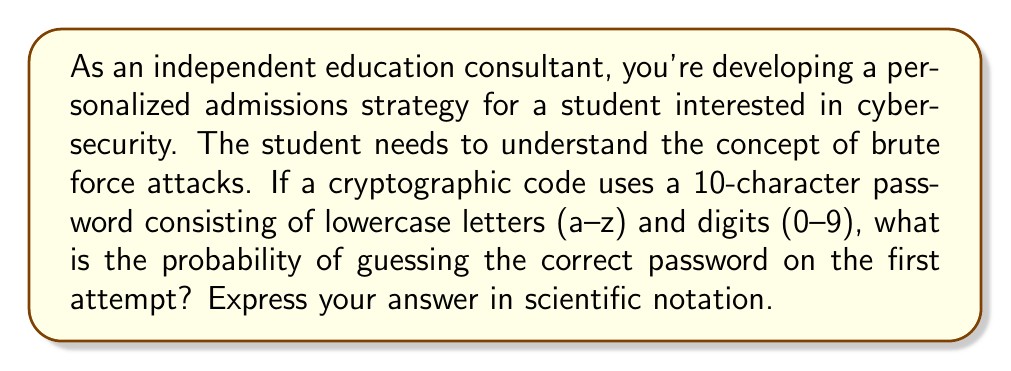Give your solution to this math problem. Let's approach this step-by-step:

1) First, we need to determine the total number of possible characters:
   - 26 lowercase letters (a-z)
   - 10 digits (0-9)
   Total: 26 + 10 = 36 possible characters

2) The password is 10 characters long, and each character can be any of the 36 possibilities.

3) This scenario follows the multiplication principle. For each character, we have 36 choices, and we need to make this choice 10 times (for each position in the password).

4) Therefore, the total number of possible passwords is:

   $$ 36^{10} = 3,656,158,440,062,976 $$

5) The probability of guessing the correct password on the first attempt is 1 divided by the total number of possible passwords:

   $$ P(\text{correct guess}) = \frac{1}{36^{10}} = \frac{1}{3,656,158,440,062,976} $$

6) To express this in scientific notation, we need to move the decimal point 15 places to the left:

   $$ 2.7352 \times 10^{-16} $$

This extremely low probability demonstrates the effectiveness of even a relatively simple password against brute force attacks, underlining the importance of strong passwords in cybersecurity.
Answer: $2.7352 \times 10^{-16}$ 